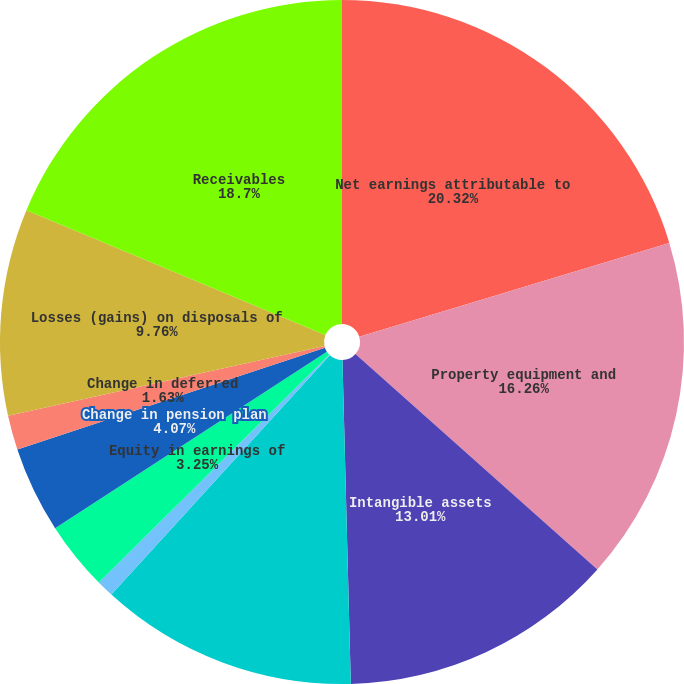Convert chart to OTSL. <chart><loc_0><loc_0><loc_500><loc_500><pie_chart><fcel>Net earnings attributable to<fcel>Property equipment and<fcel>Intangible assets<fcel>Stock based compensation<fcel>Tax benefit (deficiency) from<fcel>Equity in earnings of<fcel>Change in pension plan<fcel>Change in deferred<fcel>Losses (gains) on disposals of<fcel>Receivables<nl><fcel>20.32%<fcel>16.26%<fcel>13.01%<fcel>12.19%<fcel>0.81%<fcel>3.25%<fcel>4.07%<fcel>1.63%<fcel>9.76%<fcel>18.7%<nl></chart> 